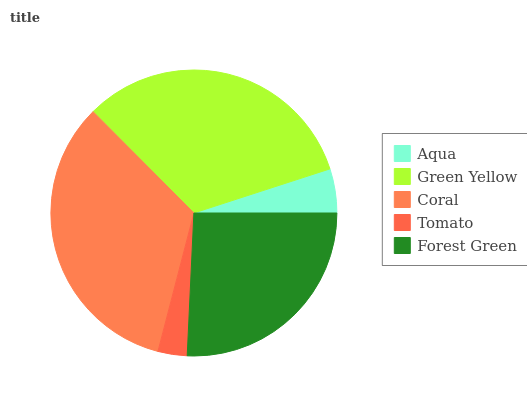Is Tomato the minimum?
Answer yes or no. Yes. Is Coral the maximum?
Answer yes or no. Yes. Is Green Yellow the minimum?
Answer yes or no. No. Is Green Yellow the maximum?
Answer yes or no. No. Is Green Yellow greater than Aqua?
Answer yes or no. Yes. Is Aqua less than Green Yellow?
Answer yes or no. Yes. Is Aqua greater than Green Yellow?
Answer yes or no. No. Is Green Yellow less than Aqua?
Answer yes or no. No. Is Forest Green the high median?
Answer yes or no. Yes. Is Forest Green the low median?
Answer yes or no. Yes. Is Coral the high median?
Answer yes or no. No. Is Tomato the low median?
Answer yes or no. No. 